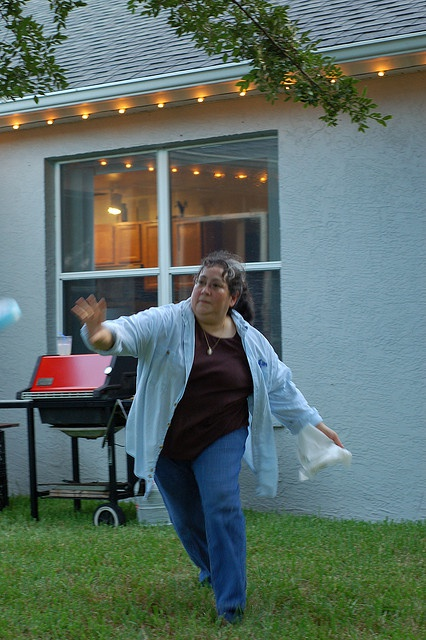Describe the objects in this image and their specific colors. I can see people in darkblue, black, gray, and navy tones and frisbee in darkblue, lightblue, and teal tones in this image. 